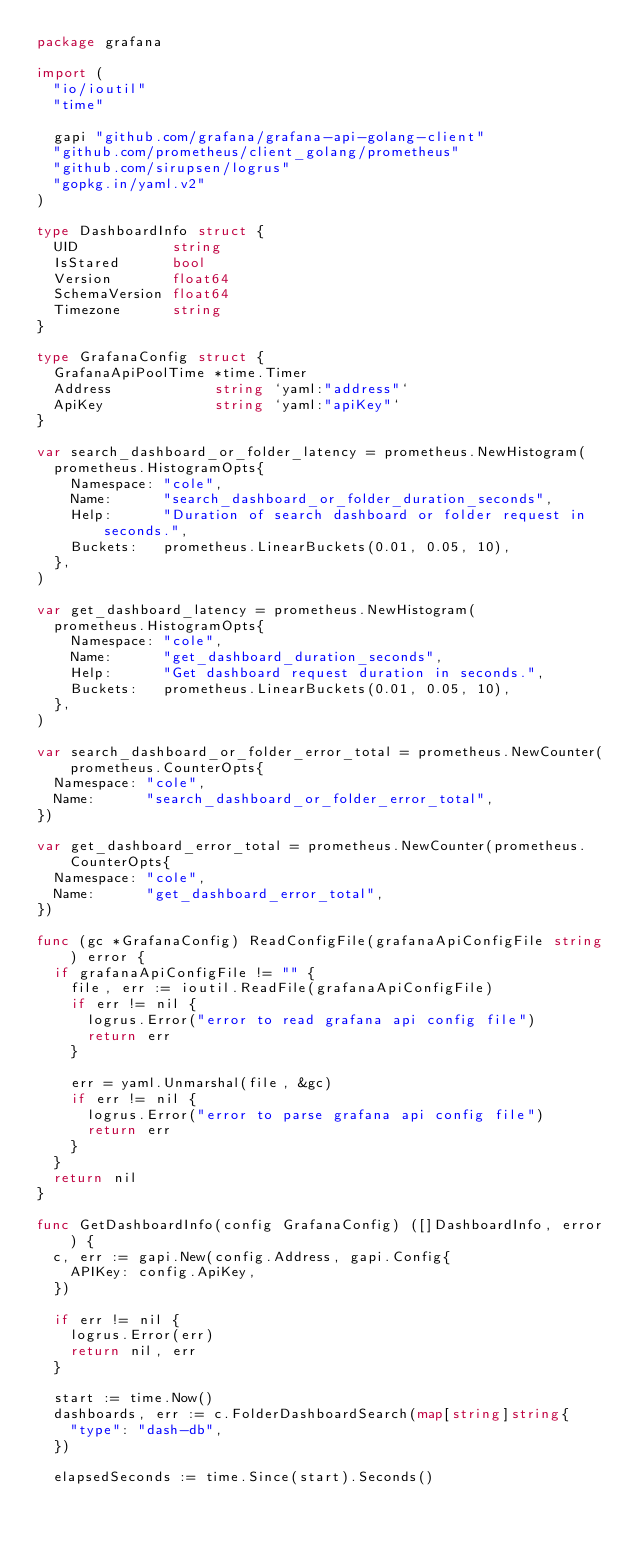<code> <loc_0><loc_0><loc_500><loc_500><_Go_>package grafana

import (
	"io/ioutil"
	"time"

	gapi "github.com/grafana/grafana-api-golang-client"
	"github.com/prometheus/client_golang/prometheus"
	"github.com/sirupsen/logrus"
	"gopkg.in/yaml.v2"
)

type DashboardInfo struct {
	UID           string
	IsStared      bool
	Version       float64
	SchemaVersion float64
	Timezone      string
}

type GrafanaConfig struct {
	GrafanaApiPoolTime *time.Timer
	Address            string `yaml:"address"`
	ApiKey             string `yaml:"apiKey"`
}

var search_dashboard_or_folder_latency = prometheus.NewHistogram(
	prometheus.HistogramOpts{
		Namespace: "cole",
		Name:      "search_dashboard_or_folder_duration_seconds",
		Help:      "Duration of search dashboard or folder request in seconds.",
		Buckets:   prometheus.LinearBuckets(0.01, 0.05, 10),
	},
)

var get_dashboard_latency = prometheus.NewHistogram(
	prometheus.HistogramOpts{
		Namespace: "cole",
		Name:      "get_dashboard_duration_seconds",
		Help:      "Get dashboard request duration in seconds.",
		Buckets:   prometheus.LinearBuckets(0.01, 0.05, 10),
	},
)

var search_dashboard_or_folder_error_total = prometheus.NewCounter(prometheus.CounterOpts{
	Namespace: "cole",
	Name:      "search_dashboard_or_folder_error_total",
})

var get_dashboard_error_total = prometheus.NewCounter(prometheus.CounterOpts{
	Namespace: "cole",
	Name:      "get_dashboard_error_total",
})

func (gc *GrafanaConfig) ReadConfigFile(grafanaApiConfigFile string) error {
	if grafanaApiConfigFile != "" {
		file, err := ioutil.ReadFile(grafanaApiConfigFile)
		if err != nil {
			logrus.Error("error to read grafana api config file")
			return err
		}

		err = yaml.Unmarshal(file, &gc)
		if err != nil {
			logrus.Error("error to parse grafana api config file")
			return err
		}
	}
	return nil
}

func GetDashboardInfo(config GrafanaConfig) ([]DashboardInfo, error) {
	c, err := gapi.New(config.Address, gapi.Config{
		APIKey: config.ApiKey,
	})

	if err != nil {
		logrus.Error(err)
		return nil, err
	}

	start := time.Now()
	dashboards, err := c.FolderDashboardSearch(map[string]string{
		"type": "dash-db",
	})

	elapsedSeconds := time.Since(start).Seconds()</code> 